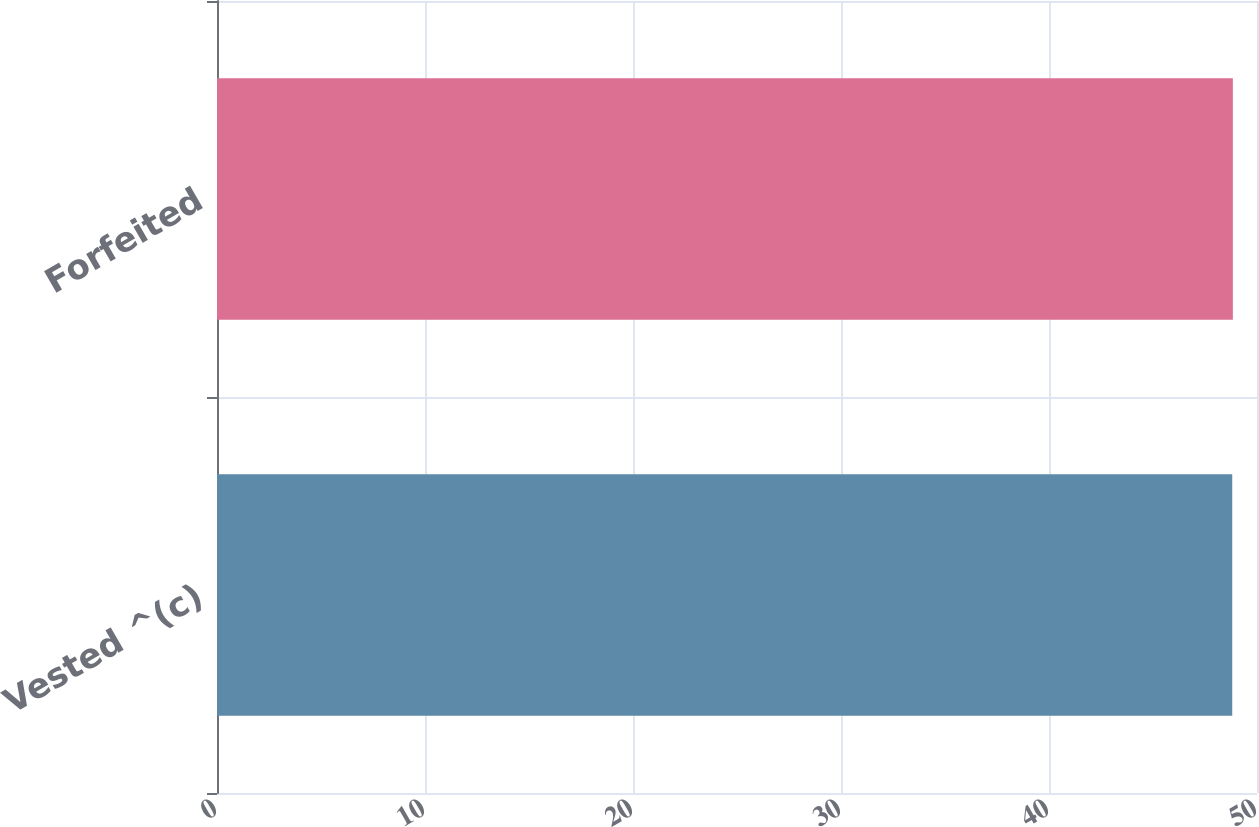Convert chart to OTSL. <chart><loc_0><loc_0><loc_500><loc_500><bar_chart><fcel>Vested ^(c)<fcel>Forfeited<nl><fcel>48.81<fcel>48.84<nl></chart> 